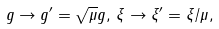Convert formula to latex. <formula><loc_0><loc_0><loc_500><loc_500>g \rightarrow g ^ { \prime } = \sqrt { \mu } g , \, \xi \rightarrow \xi ^ { \prime } = \xi / \mu ,</formula> 